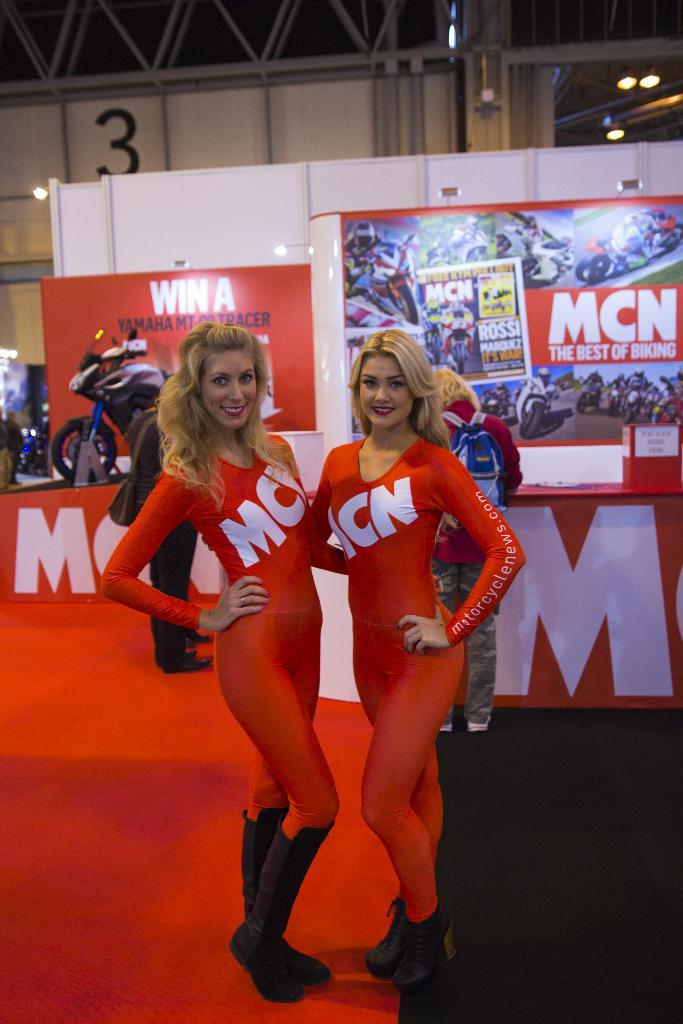Are they working for mcn?
Give a very brief answer. Yes. What is the name on the shirts?
Your answer should be compact. Mcn. 